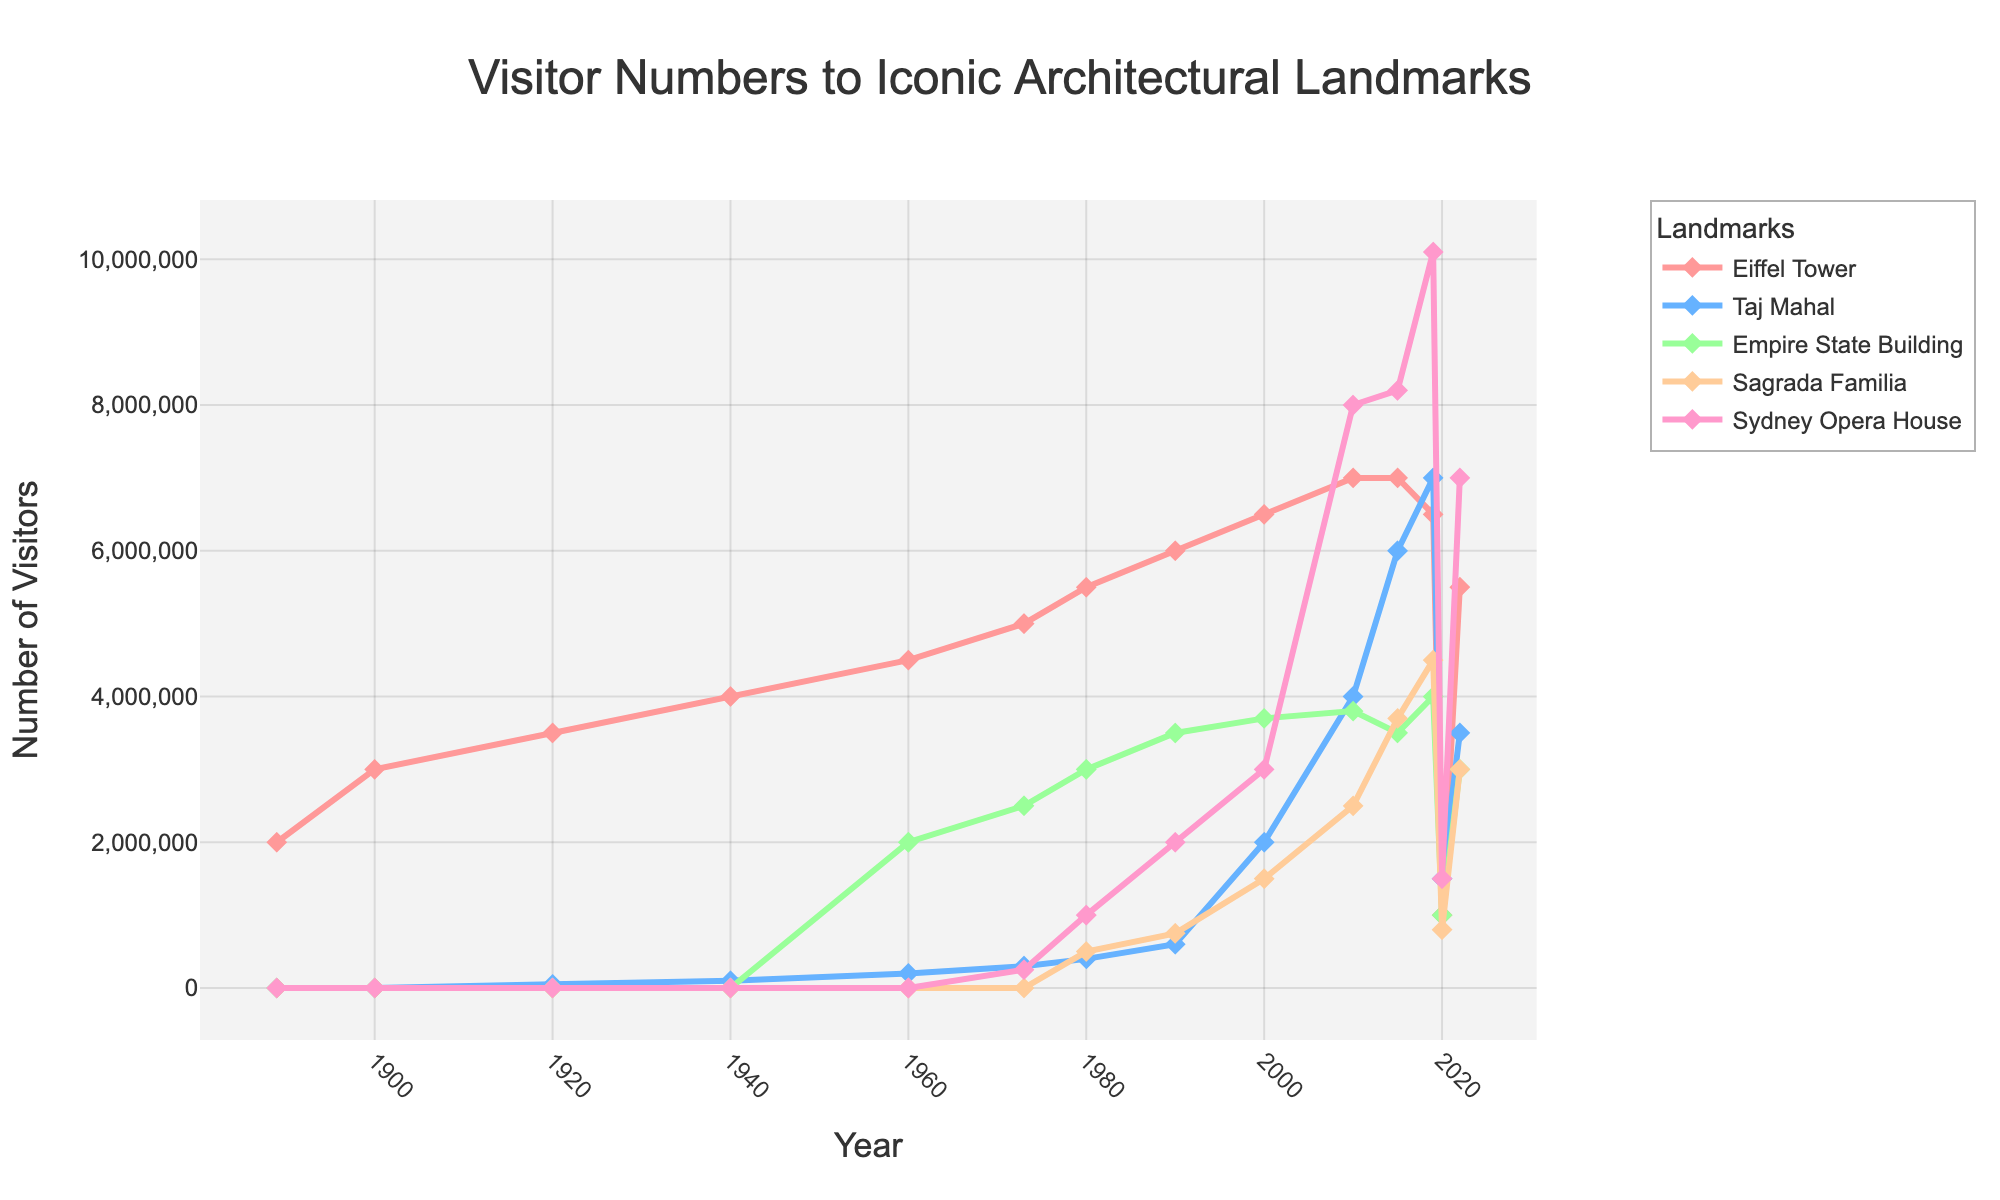What's the landmark with the highest number of visitors in 2019? Look for the highest point on the y-axis for the year 2019. The Sydney Opera House reaches the highest point.
Answer: Sydney Opera House How many visitors did the Eiffel Tower and the Taj Mahal have combined in 2020? Find the values for the Eiffel Tower and the Taj Mahal in 2020 and sum them up. The Eiffel Tower has 1,000,000 and the Taj Mahal has 1,500,000 visitors. Combined, they have 1,000,000 + 1,500,000 = 2,500,000 visitors.
Answer: 2,500,000 Which landmark saw the largest decrease in visitors between 2019 and 2020? Compare the drop in visitor numbers for each landmark between 2019 and 2020. The Sydney Opera House shows the largest drop, from 10,100,000 to 1,500,000.
Answer: Sydney Opera House Among the landmarks, which has the most consistent visitor numbers from 2010 to 2015? Look at the trends from 2010 to 2015. The Eiffel Tower maintains a steady visitor number of 7,000,000 during this period.
Answer: Eiffel Tower Which two landmarks had equal visitor numbers in 2022? Identify the landmarks with the same value in 2022. Both the Empire State Building and the Sagrada Familia have 3,000,000 visitors.
Answer: Empire State Building and Sagrada Familia What's the average number of visitors to the Sydney Opera House from 2000 to 2022? Sum the visitors to the Sydney Opera House from 2000 (3,000,000) to 2022 (7,000,000) and divide by the number of data points (7). (3,000,000 + 8,000,000 + 8,200,000 + 10,100,000 + 1,500,000 + 7,000,000) / 6 = 38,800,000 / 6 ≈ 6,466,666.67
Answer: 6,466,666.67 What year did the Sagrada Familia first appear in the data? Identify the earliest year in the chart with a non-zero value for the Sagrada Familia. It first appears in 1980.
Answer: 1980 How did the visitor numbers of the Empire State Building change from its opening in 1960 to 1980? Find the values for 1960 and 1980 for the Empire State Building and calculate the difference. The numbers rise from 2,000,000 in 1960 to 3,000,000 in 1980, a change of 3,000,000 - 2,000,000 = 1,000,000.
Answer: Increased by 1,000,000 Considering the trends, which landmark seems the least affected by global events such as pandemics? Look for the landmark with the smallest drop in 2020 and quickest recovery by 2022. The Taj Mahal only drops to 1,500,000 in 2020 but rises to 3,500,000 by 2022.
Answer: Taj Mahal 